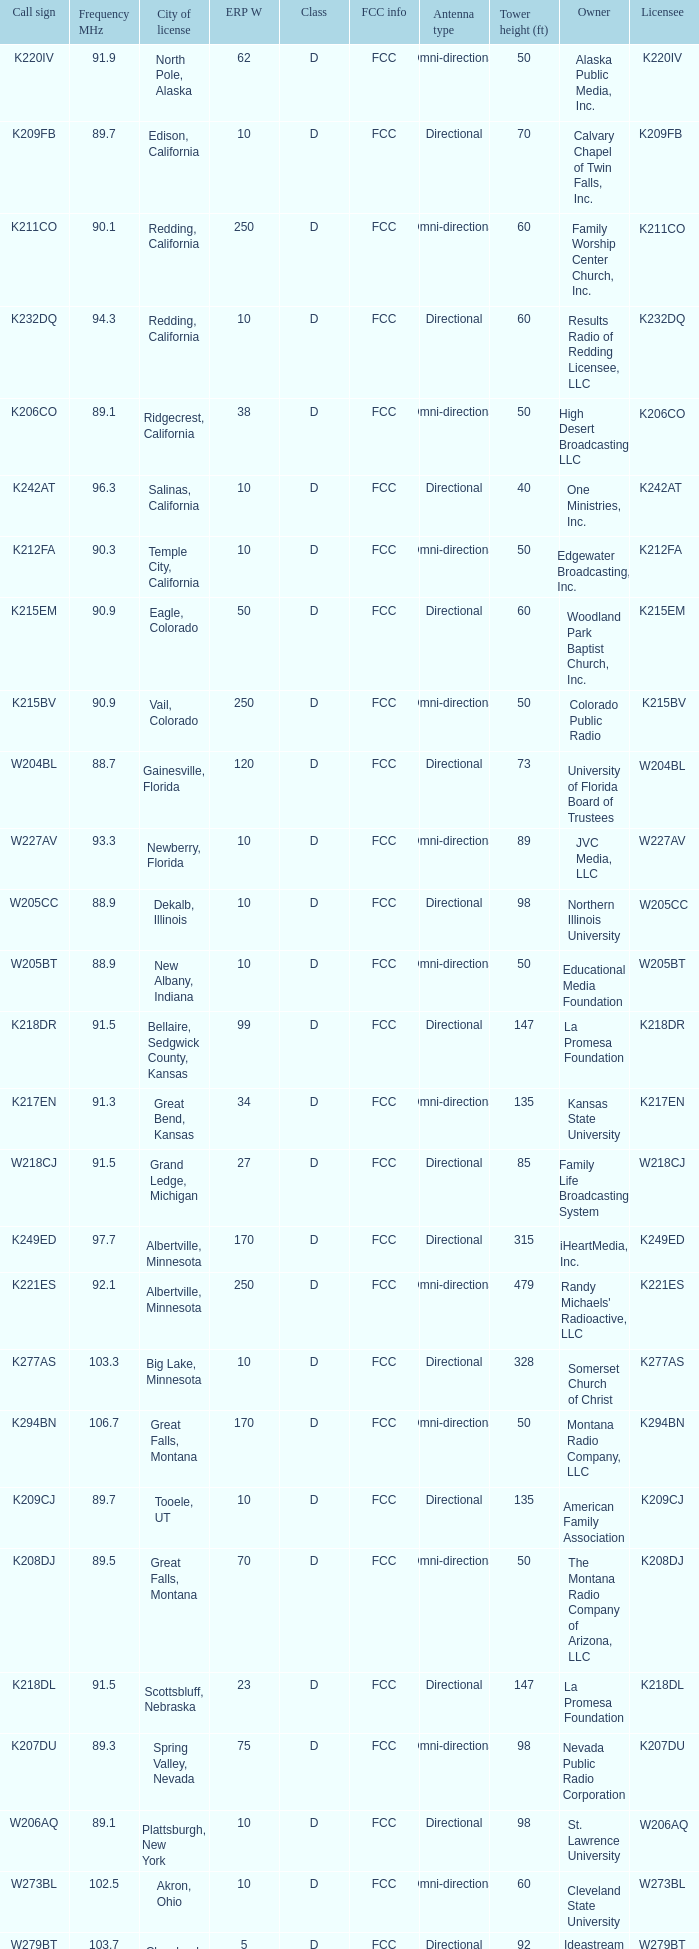What is the call sign of the translator with an ERP W greater than 38 and a city license from Great Falls, Montana? K294BN, K208DJ. 